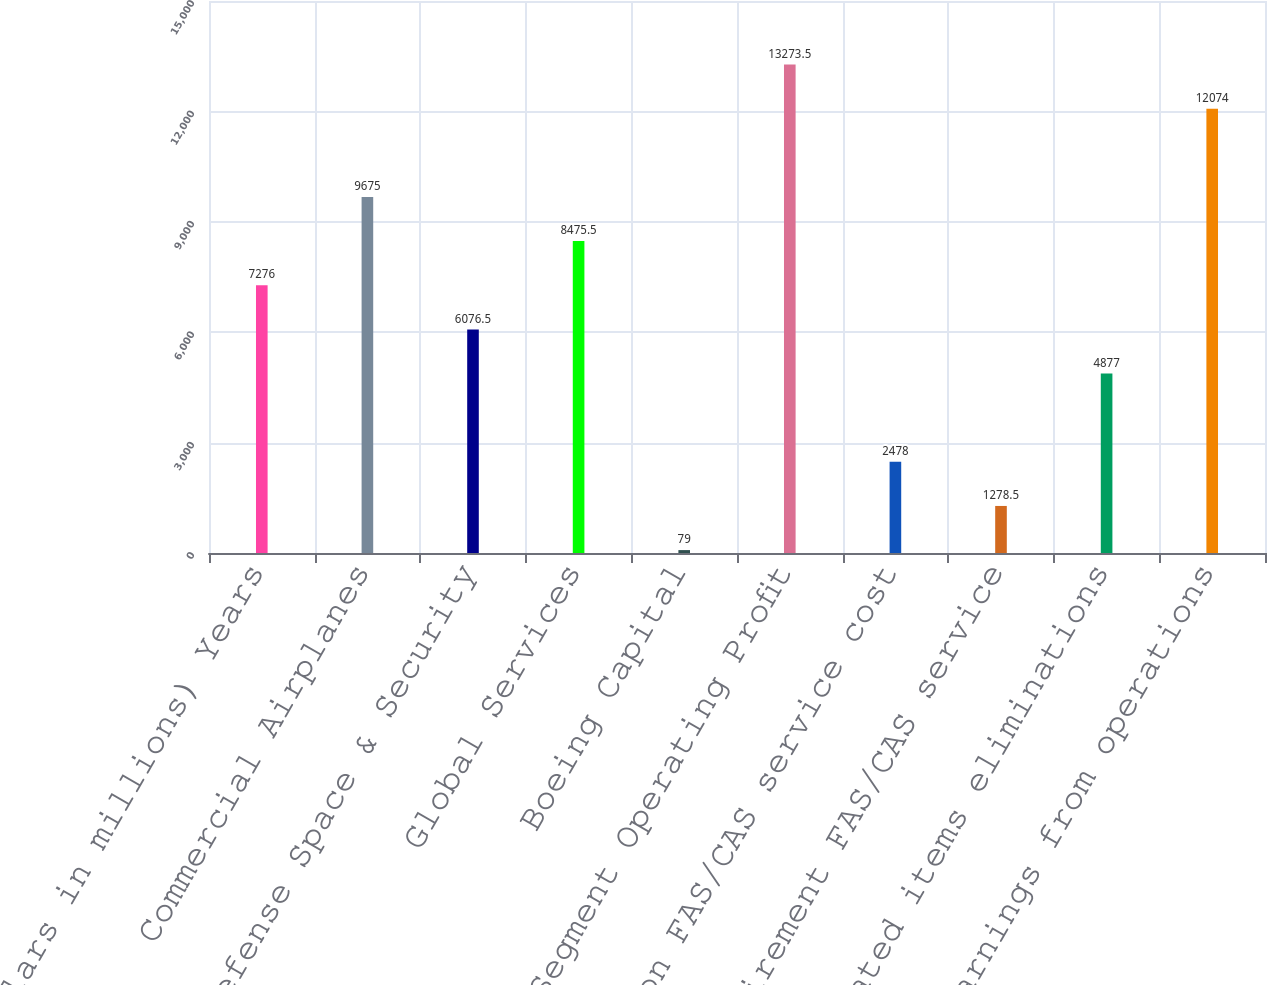Convert chart. <chart><loc_0><loc_0><loc_500><loc_500><bar_chart><fcel>(Dollars in millions) Years<fcel>Commercial Airplanes<fcel>Defense Space & Security<fcel>Global Services<fcel>Boeing Capital<fcel>Segment Operating Profit<fcel>Pension FAS/CAS service cost<fcel>Postretirement FAS/CAS service<fcel>Unallocated items eliminations<fcel>Earnings from operations<nl><fcel>7276<fcel>9675<fcel>6076.5<fcel>8475.5<fcel>79<fcel>13273.5<fcel>2478<fcel>1278.5<fcel>4877<fcel>12074<nl></chart> 